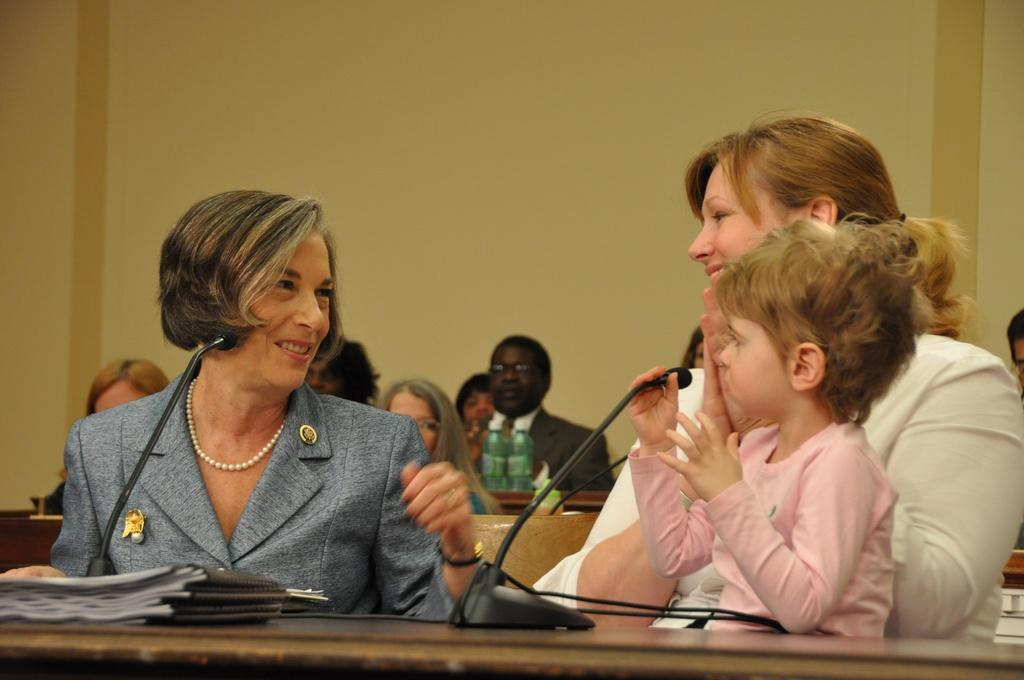How many people are in the image? There are two women in the image. What are the women doing in the image? The women are sitting and smiling at each other. What object is in front of the women? There is a microphone in front of the women. What type of zephyr can be seen blowing through the women's hair in the image? There is no zephyr present in the image, and the women's hair is not being blown by any wind. How does the heat affect the women's comfort in the image? The provided facts do not mention any heat or temperature, so we cannot determine its effect on the women's comfort. 